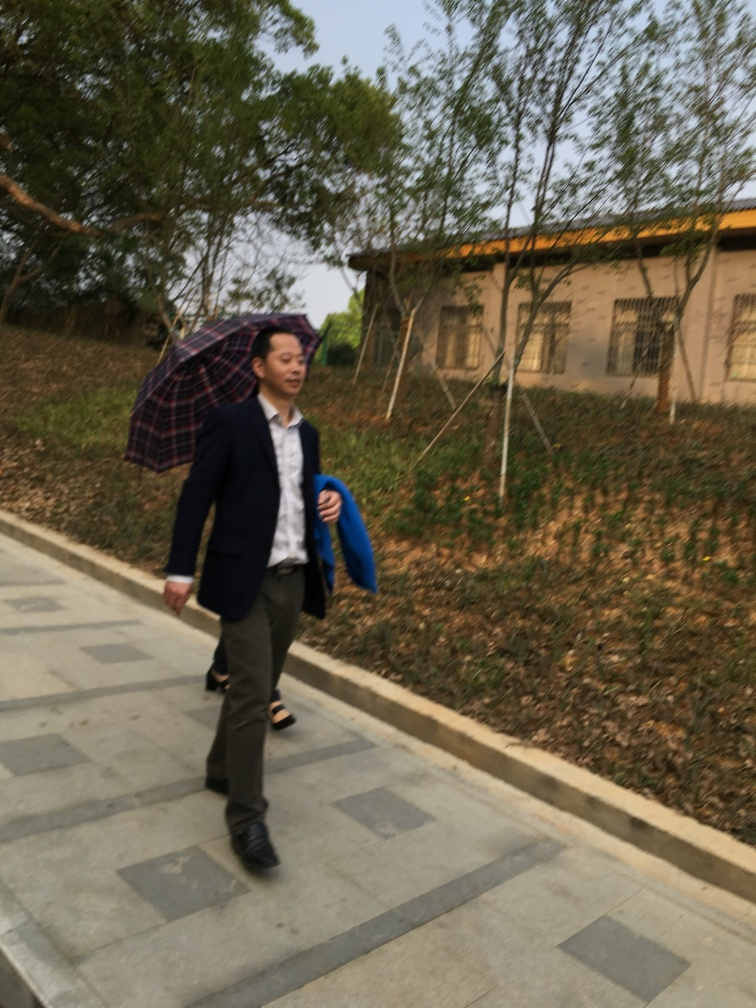How is the main subject in this photo?
A. Blurry with no texture details
B. Invisible
C. Slightly blurry but retains most texture details
Answer with the option's letter from the given choices directly.
 C. 